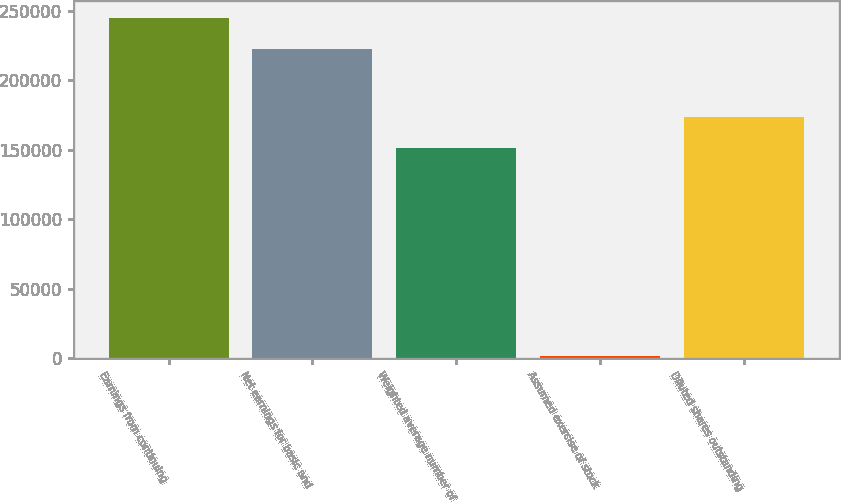Convert chart. <chart><loc_0><loc_0><loc_500><loc_500><bar_chart><fcel>Earnings from continuing<fcel>Net earnings for basic and<fcel>Weighted average number of<fcel>Assumed exercise of stock<fcel>Diluted shares outstanding<nl><fcel>244738<fcel>222398<fcel>151634<fcel>1960<fcel>173974<nl></chart> 